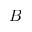<formula> <loc_0><loc_0><loc_500><loc_500>B</formula> 